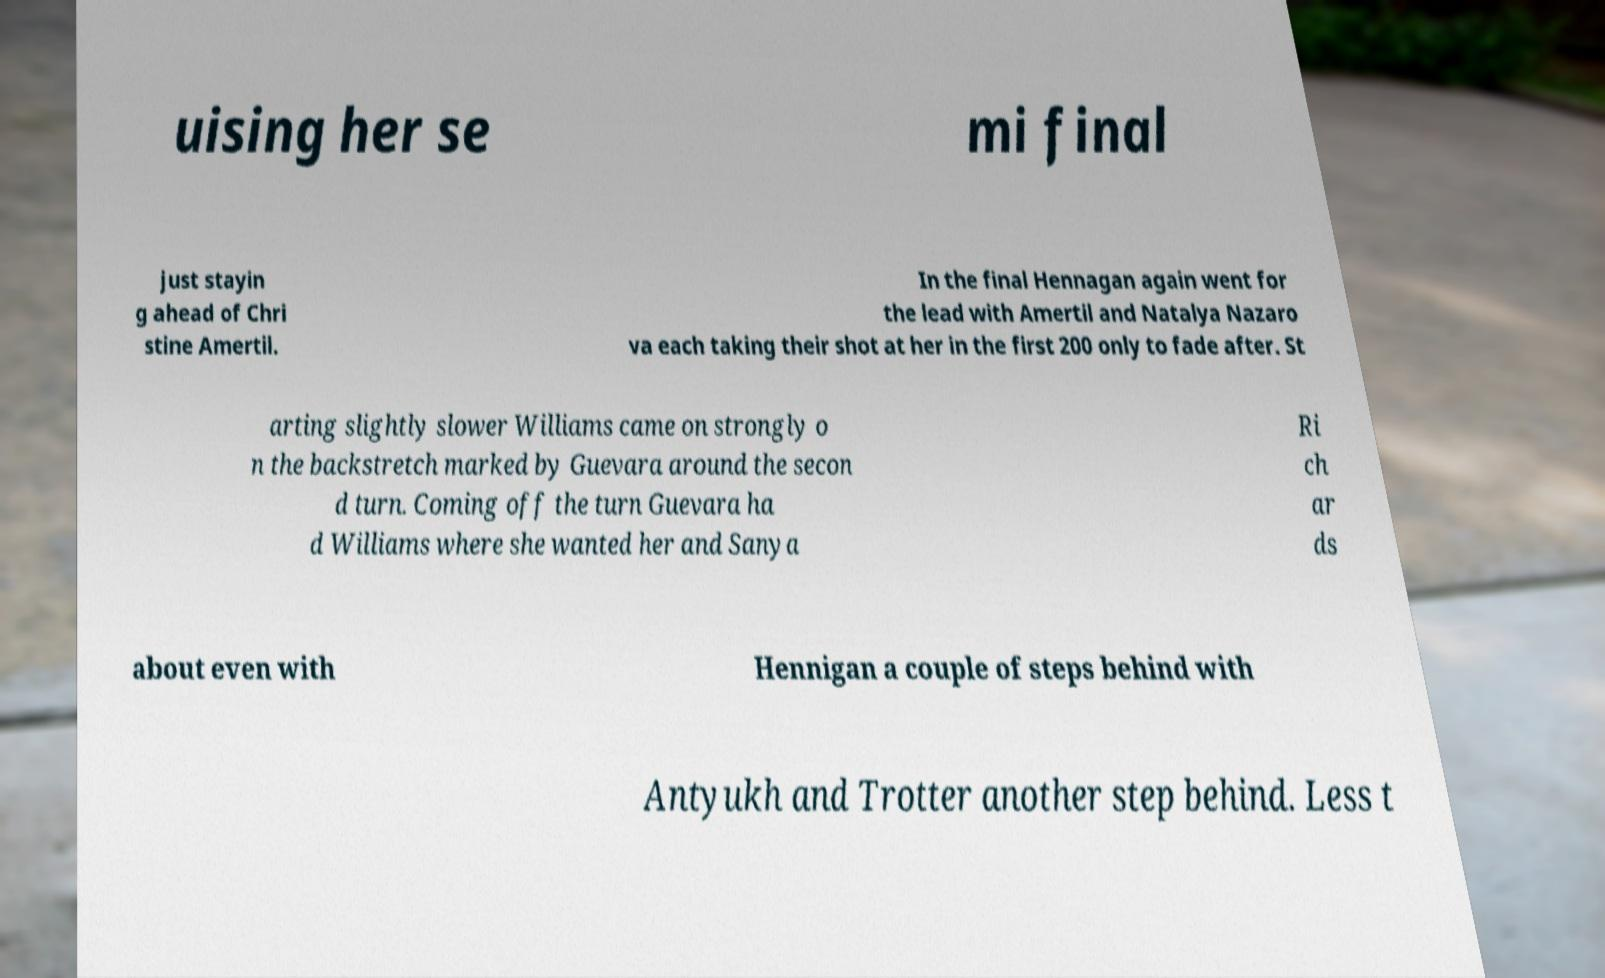Can you accurately transcribe the text from the provided image for me? uising her se mi final just stayin g ahead of Chri stine Amertil. In the final Hennagan again went for the lead with Amertil and Natalya Nazaro va each taking their shot at her in the first 200 only to fade after. St arting slightly slower Williams came on strongly o n the backstretch marked by Guevara around the secon d turn. Coming off the turn Guevara ha d Williams where she wanted her and Sanya Ri ch ar ds about even with Hennigan a couple of steps behind with Antyukh and Trotter another step behind. Less t 